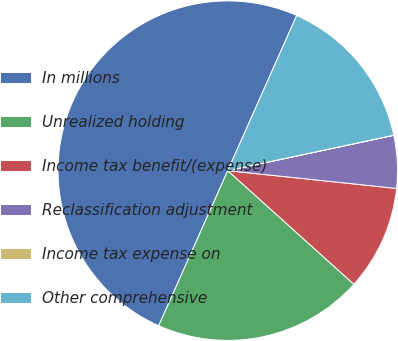Convert chart. <chart><loc_0><loc_0><loc_500><loc_500><pie_chart><fcel>In millions<fcel>Unrealized holding<fcel>Income tax benefit/(expense)<fcel>Reclassification adjustment<fcel>Income tax expense on<fcel>Other comprehensive<nl><fcel>49.98%<fcel>20.0%<fcel>10.0%<fcel>5.01%<fcel>0.01%<fcel>15.0%<nl></chart> 